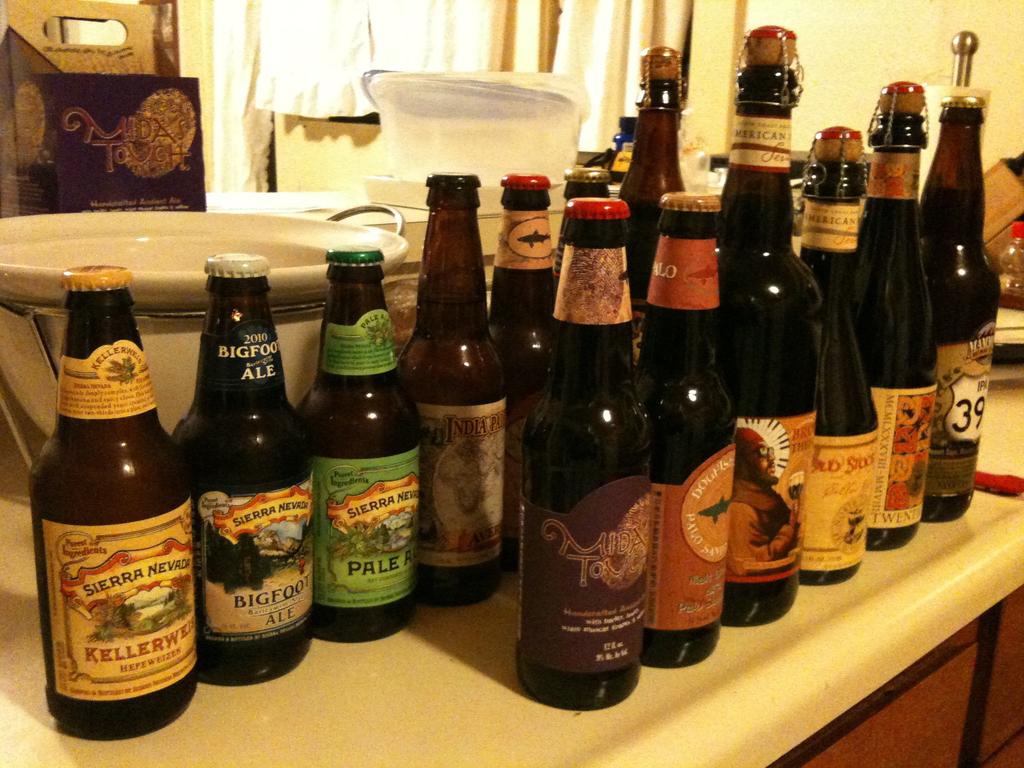What brand of bottle is the first bottle on the back row?
Give a very brief answer. Sierra nevada. 